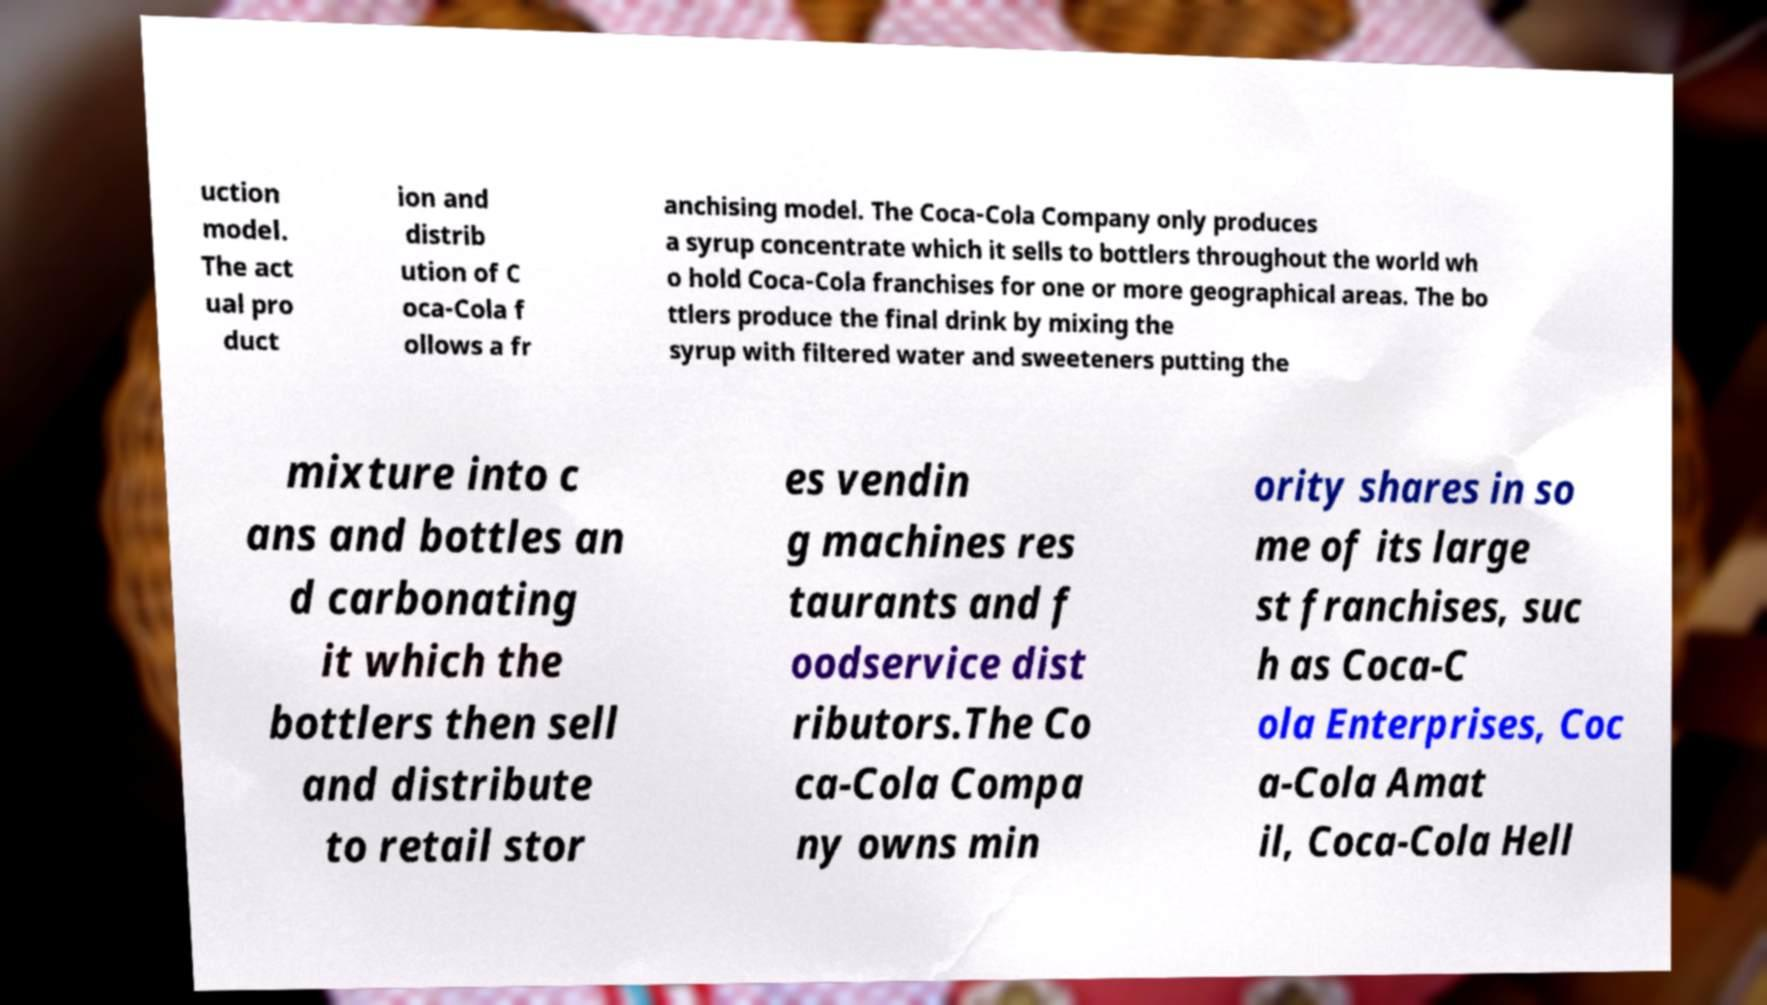Could you assist in decoding the text presented in this image and type it out clearly? uction model. The act ual pro duct ion and distrib ution of C oca-Cola f ollows a fr anchising model. The Coca-Cola Company only produces a syrup concentrate which it sells to bottlers throughout the world wh o hold Coca-Cola franchises for one or more geographical areas. The bo ttlers produce the final drink by mixing the syrup with filtered water and sweeteners putting the mixture into c ans and bottles an d carbonating it which the bottlers then sell and distribute to retail stor es vendin g machines res taurants and f oodservice dist ributors.The Co ca-Cola Compa ny owns min ority shares in so me of its large st franchises, suc h as Coca-C ola Enterprises, Coc a-Cola Amat il, Coca-Cola Hell 